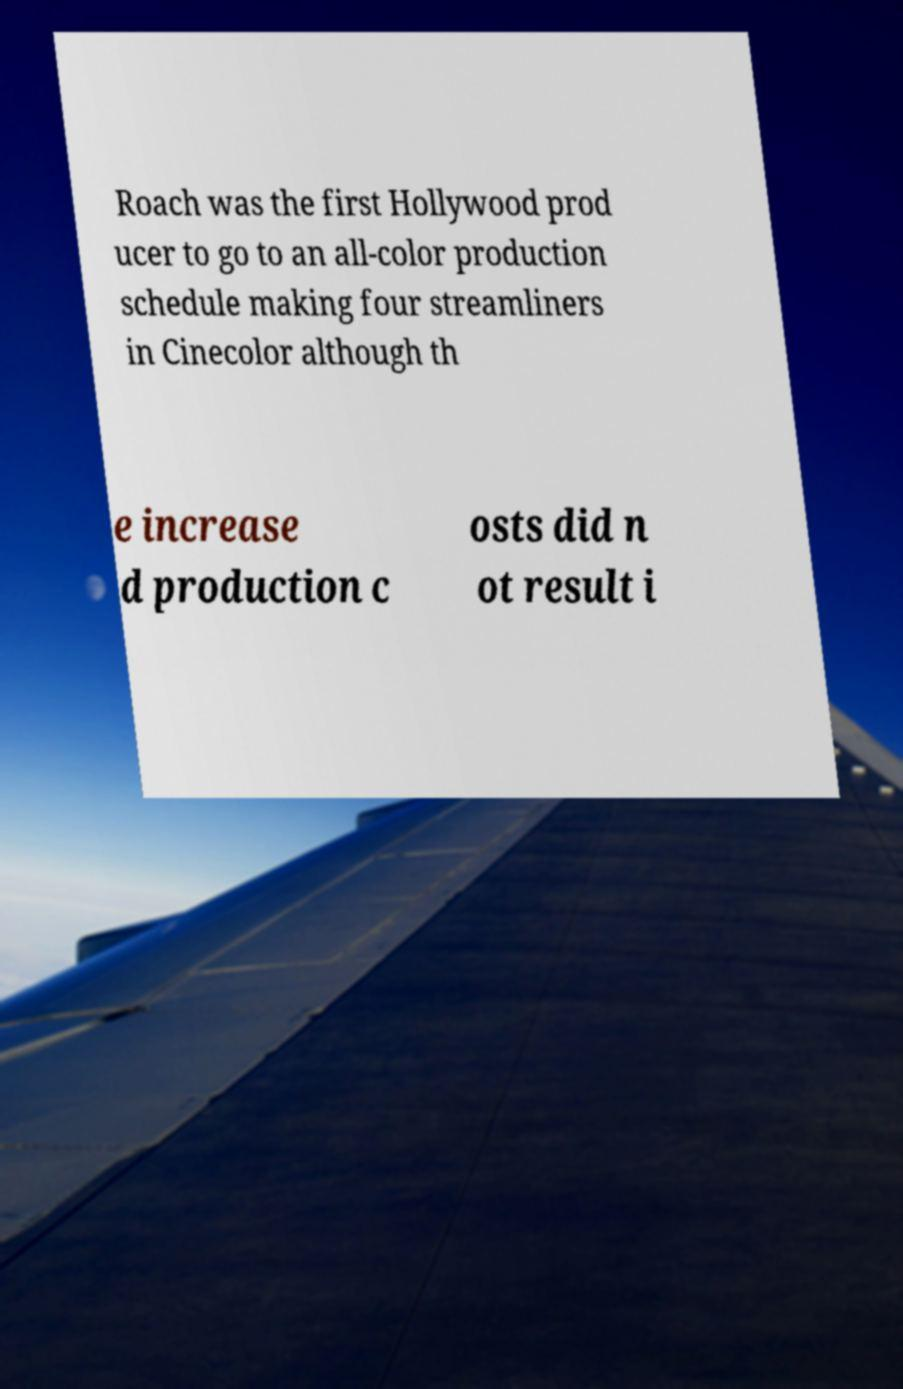Please identify and transcribe the text found in this image. Roach was the first Hollywood prod ucer to go to an all-color production schedule making four streamliners in Cinecolor although th e increase d production c osts did n ot result i 